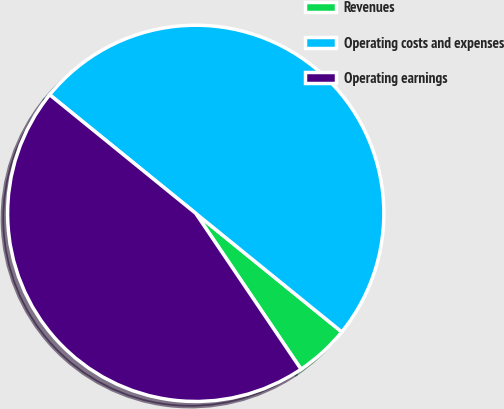<chart> <loc_0><loc_0><loc_500><loc_500><pie_chart><fcel>Revenues<fcel>Operating costs and expenses<fcel>Operating earnings<nl><fcel>4.69%<fcel>50.0%<fcel>45.31%<nl></chart> 